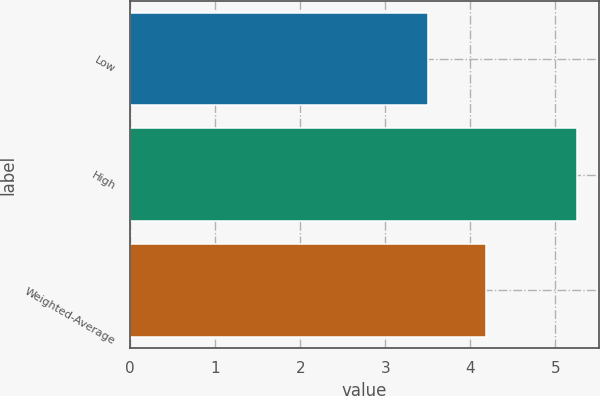<chart> <loc_0><loc_0><loc_500><loc_500><bar_chart><fcel>Low<fcel>High<fcel>Weighted-Average<nl><fcel>3.5<fcel>5.25<fcel>4.18<nl></chart> 